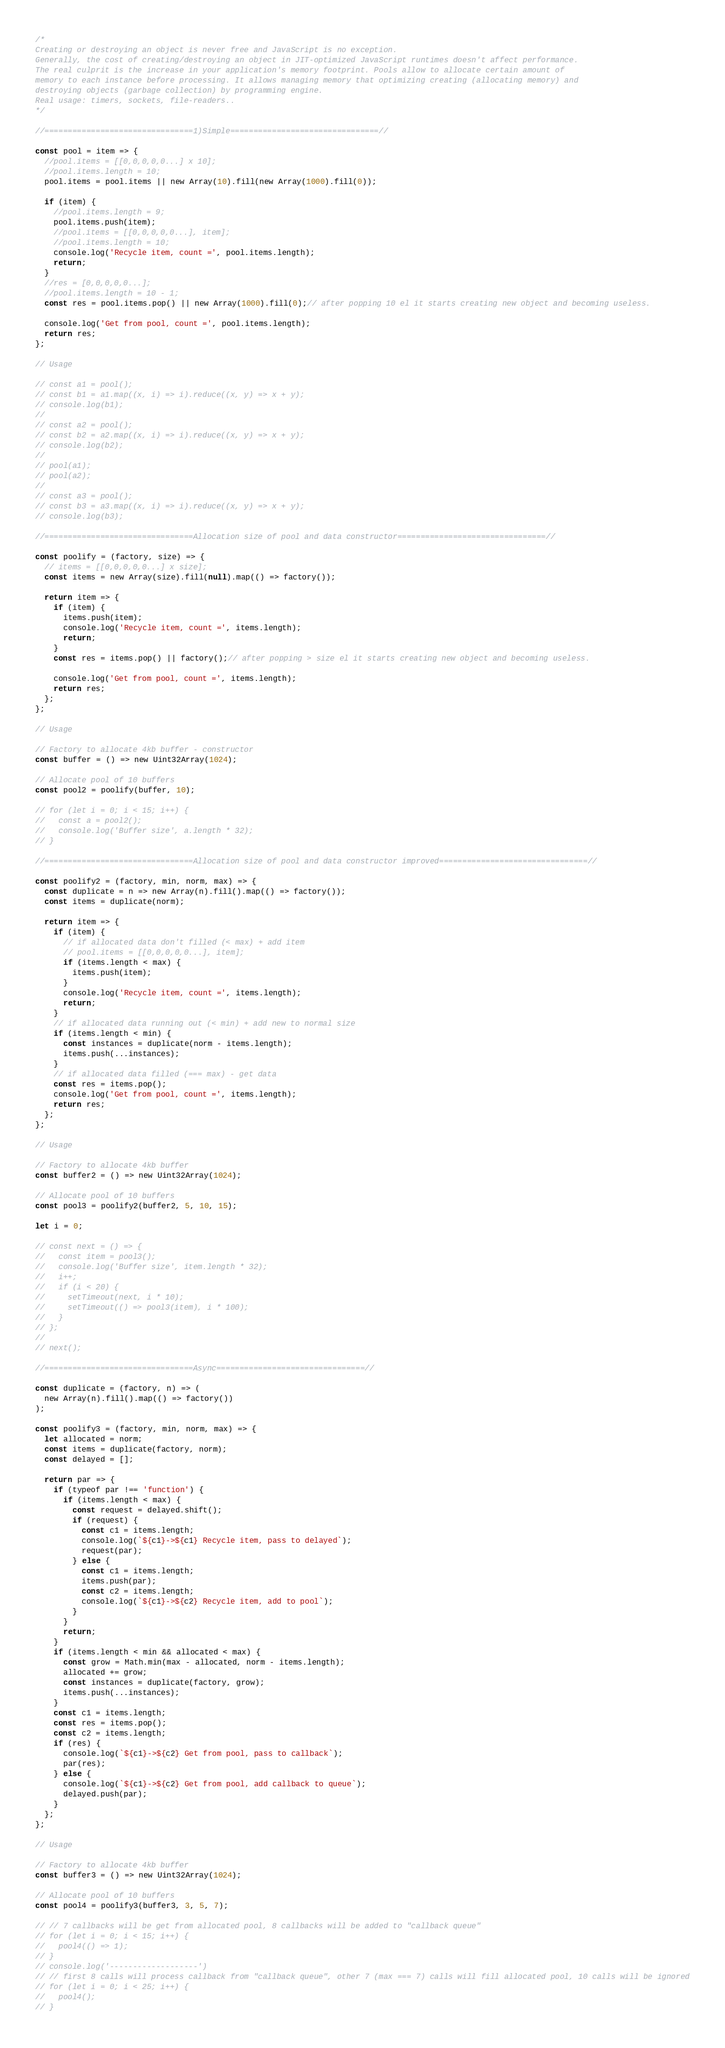Convert code to text. <code><loc_0><loc_0><loc_500><loc_500><_JavaScript_>/*
Creating or destroying an object is never free and JavaScript is no exception.
Generally, the cost of creating/destroying an object in JIT-optimized JavaScript runtimes doesn't affect performance.
The real culprit is the increase in your application's memory footprint. Pools allow to allocate certain amount of
memory to each instance before processing. It allows managing memory that optimizing creating (allocating memory) and
destroying objects (garbage collection) by programming engine.
Real usage: timers, sockets, file-readers..
*/

//================================1)Simple================================//

const pool = item => {
  //pool.items = [[0,0,0,0,0...] x 10];
  //pool.items.length = 10;
  pool.items = pool.items || new Array(10).fill(new Array(1000).fill(0));

  if (item) {
    //pool.items.length = 9;
    pool.items.push(item);
    //pool.items = [[0,0,0,0,0...], item];
    //pool.items.length = 10;
    console.log('Recycle item, count =', pool.items.length);
    return;
  }
  //res = [0,0,0,0,0...];
  //pool.items.length = 10 - 1;
  const res = pool.items.pop() || new Array(1000).fill(0);// after popping 10 el it starts creating new object and becoming useless.

  console.log('Get from pool, count =', pool.items.length);
  return res;
};

// Usage

// const a1 = pool();
// const b1 = a1.map((x, i) => i).reduce((x, y) => x + y);
// console.log(b1);
//
// const a2 = pool();
// const b2 = a2.map((x, i) => i).reduce((x, y) => x + y);
// console.log(b2);
//
// pool(a1);
// pool(a2);
//
// const a3 = pool();
// const b3 = a3.map((x, i) => i).reduce((x, y) => x + y);
// console.log(b3);

//================================Allocation size of pool and data constructor================================//

const poolify = (factory, size) => {
  // items = [[0,0,0,0,0...] x size];
  const items = new Array(size).fill(null).map(() => factory());

  return item => {
    if (item) {
      items.push(item);
      console.log('Recycle item, count =', items.length);
      return;
    }
    const res = items.pop() || factory();// after popping > size el it starts creating new object and becoming useless.

    console.log('Get from pool, count =', items.length);
    return res;
  };
};

// Usage

// Factory to allocate 4kb buffer - constructor
const buffer = () => new Uint32Array(1024);

// Allocate pool of 10 buffers
const pool2 = poolify(buffer, 10);

// for (let i = 0; i < 15; i++) {
//   const a = pool2();
//   console.log('Buffer size', a.length * 32);
// }

//================================Allocation size of pool and data constructor improved================================//

const poolify2 = (factory, min, norm, max) => {
  const duplicate = n => new Array(n).fill().map(() => factory());
  const items = duplicate(norm);

  return item => {
    if (item) {
      // if allocated data don't filled (< max) + add item
      // pool.items = [[0,0,0,0,0...], item];
      if (items.length < max) {
        items.push(item);
      }
      console.log('Recycle item, count =', items.length);
      return;
    }
    // if allocated data running out (< min) + add new to normal size
    if (items.length < min) {
      const instances = duplicate(norm - items.length);
      items.push(...instances);
    }
    // if allocated data filled (=== max) - get data
    const res = items.pop();
    console.log('Get from pool, count =', items.length);
    return res;
  };
};

// Usage

// Factory to allocate 4kb buffer
const buffer2 = () => new Uint32Array(1024);

// Allocate pool of 10 buffers
const pool3 = poolify2(buffer2, 5, 10, 15);

let i = 0;

// const next = () => {
//   const item = pool3();
//   console.log('Buffer size', item.length * 32);
//   i++;
//   if (i < 20) {
//     setTimeout(next, i * 10);
//     setTimeout(() => pool3(item), i * 100);
//   }
// };
//
// next();

//================================Async================================//

const duplicate = (factory, n) => (
  new Array(n).fill().map(() => factory())
);

const poolify3 = (factory, min, norm, max) => {
  let allocated = norm;
  const items = duplicate(factory, norm);
  const delayed = [];

  return par => {
    if (typeof par !== 'function') {
      if (items.length < max) {
        const request = delayed.shift();
        if (request) {
          const c1 = items.length;
          console.log(`${c1}->${c1} Recycle item, pass to delayed`);
          request(par);
        } else {
          const c1 = items.length;
          items.push(par);
          const c2 = items.length;
          console.log(`${c1}->${c2} Recycle item, add to pool`);
        }
      }
      return;
    }
    if (items.length < min && allocated < max) {
      const grow = Math.min(max - allocated, norm - items.length);
      allocated += grow;
      const instances = duplicate(factory, grow);
      items.push(...instances);
    }
    const c1 = items.length;
    const res = items.pop();
    const c2 = items.length;
    if (res) {
      console.log(`${c1}->${c2} Get from pool, pass to callback`);
      par(res);
    } else {
      console.log(`${c1}->${c2} Get from pool, add callback to queue`);
      delayed.push(par);
    }
  };
};

// Usage

// Factory to allocate 4kb buffer
const buffer3 = () => new Uint32Array(1024);

// Allocate pool of 10 buffers
const pool4 = poolify3(buffer3, 3, 5, 7);

// // 7 callbacks will be get from allocated pool, 8 callbacks will be added to "callback queue"
// for (let i = 0; i < 15; i++) {
//   pool4(() => 1);
// }
// console.log('-------------------')
// // first 8 calls will process callback from "callback queue", other 7 (max === 7) calls will fill allocated pool, 10 calls will be ignored
// for (let i = 0; i < 25; i++) {
//   pool4();
// }</code> 